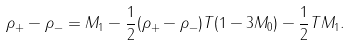Convert formula to latex. <formula><loc_0><loc_0><loc_500><loc_500>\rho _ { + } - \rho _ { - } = M _ { 1 } - \frac { 1 } { 2 } ( \rho _ { + } - \rho _ { - } ) T ( 1 - 3 M _ { 0 } ) - \frac { 1 } { 2 } T M _ { 1 } .</formula> 